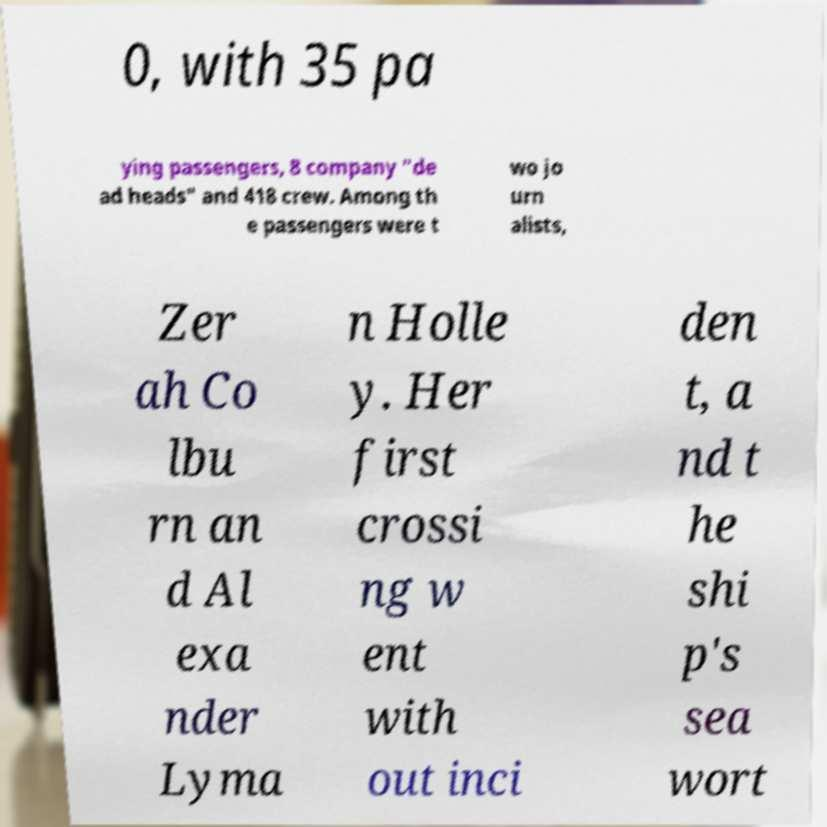Can you read and provide the text displayed in the image?This photo seems to have some interesting text. Can you extract and type it out for me? 0, with 35 pa ying passengers, 8 company "de ad heads" and 418 crew. Among th e passengers were t wo jo urn alists, Zer ah Co lbu rn an d Al exa nder Lyma n Holle y. Her first crossi ng w ent with out inci den t, a nd t he shi p's sea wort 